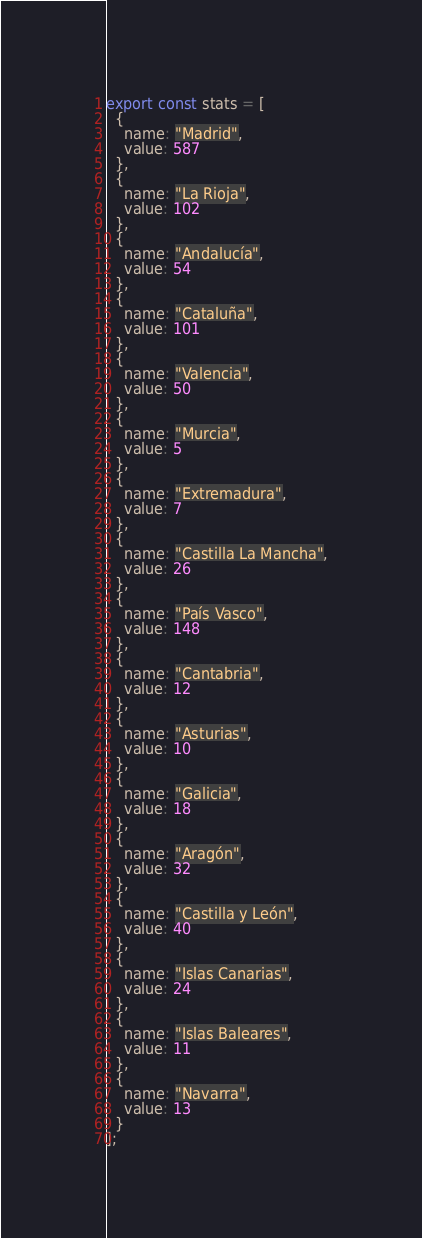Convert code to text. <code><loc_0><loc_0><loc_500><loc_500><_TypeScript_>export const stats = [
  {
    name: "Madrid",
    value: 587
  },
  {
    name: "La Rioja",
    value: 102
  },
  {
    name: "Andalucía",
    value: 54
  },
  {
    name: "Cataluña",
    value: 101
  },
  {
    name: "Valencia",
    value: 50
  },
  {
    name: "Murcia",
    value: 5
  },
  {
    name: "Extremadura",
    value: 7
  },
  {
    name: "Castilla La Mancha",
    value: 26
  },
  {
    name: "País Vasco",
    value: 148
  },
  {
    name: "Cantabria",
    value: 12
  },
  {
    name: "Asturias",
    value: 10
  },
  {
    name: "Galicia",
    value: 18
  },
  {
    name: "Aragón",
    value: 32
  },
  {
    name: "Castilla y León",
    value: 40
  },
  {
    name: "Islas Canarias",
    value: 24
  },
  {
    name: "Islas Baleares",
    value: 11
  },
  {
    name: "Navarra",
    value: 13
  }
];
</code> 